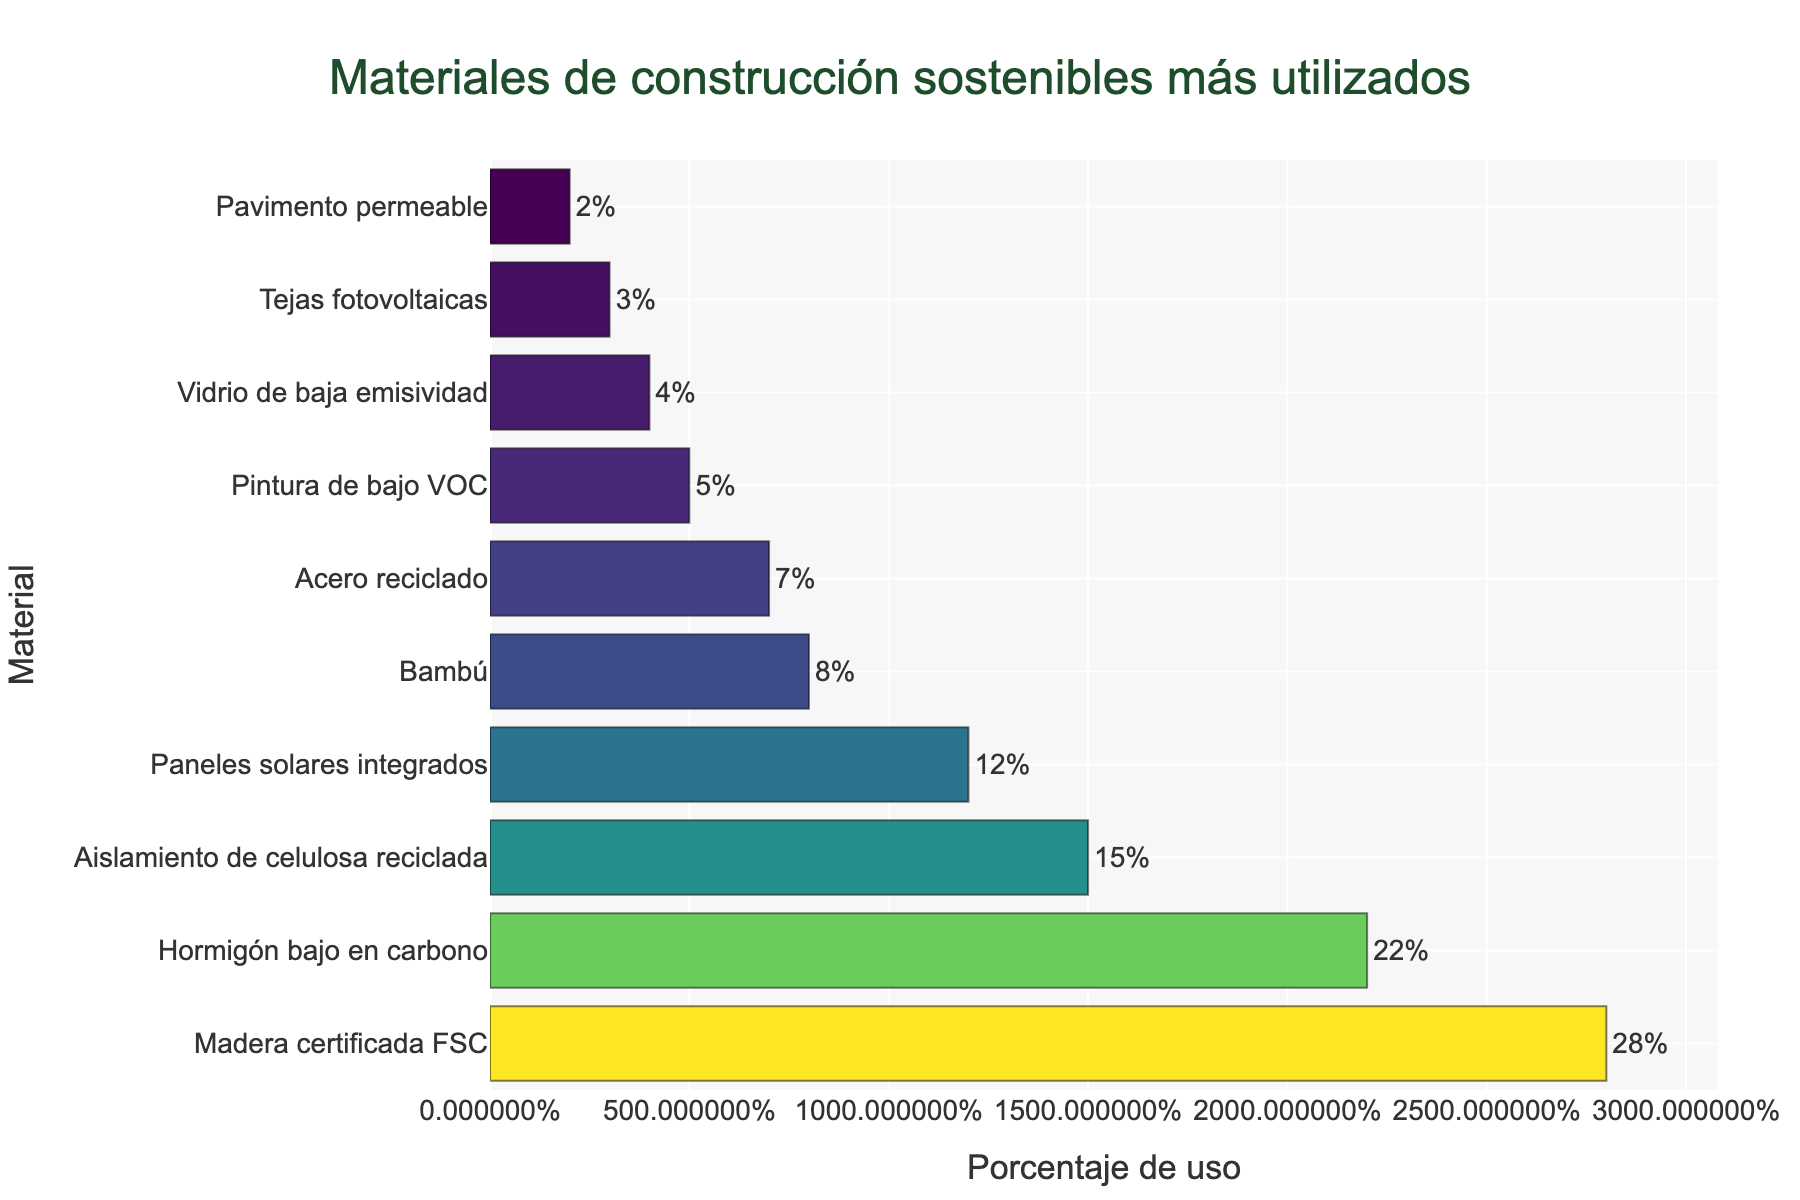¿Cuál es el material de construcción sostenible más utilizado? Observando el gráfico, el material con el porcentaje más alto de uso es "Madera certificada FSC" con un 28%.
Answer: Madera certificada FSC ¿Cuál es el porcentaje de uso combinado de Hormigón bajo en carbono y Aislamiento de celulosa reciclada? Sumamos los porcentajes de uso de ambos materiales: 22% (Hormigón) + 15% (Aislamiento) = 37%.
Answer: 37% Comparando el uso de Bambú y Acero reciclado, ¿cuál es mayor y por cuánto? El uso de Bambú es 8%, mientras que el uso de Acero reciclado es 7%. La diferencia es 8% - 7% = 1%. Por lo tanto, Bambú se usa un 1% más que el Acero reciclado.
Answer: Bambú, 1% ¿Cuál es la diferencia en el porcentaje de uso entre el material más utilizado y el menos utilizado? El material más utilizado es "Madera certificada FSC" con 28% y el menos utilizado es "Pavimento permeable" con 2%. La diferencia es 28% - 2% = 26%.
Answer: 26% ¿Qué porcentaje de uso tiene Pintura de bajo VOC comparado con Vidrio de baja emisividad? La Pintura de bajo VOC tiene un uso del 5%, mientras que el Vidrio de baja emisividad tiene un uso del 4%. La comparación muestra que la pintura tiene un 1% más de uso que el vidrio.
Answer: 1% Si sumamos los porcentajes de uso de los tres materiales más utilizados, ¿qué resultado obtenemos? Sumamos los porcentajes de "Madera certificada FSC" (28%), "Hormigón bajo en carbono" (22%) y "Aislamiento de celulosa reciclada" (15%): 28% + 22% + 15% = 65%.
Answer: 65% ¿Cuáles son los dos materiales menos utilizados y cuál es la diferencia en sus porcentajes de uso? Los dos materiales menos utilizados son "Pavimento permeable" con 2% y "Tejas fotovoltaicas" con 3%. La diferencia en sus porcentajes de uso es 3% - 2% = 1%.
Answer: Pavimento permeable y Tejas fotovoltaicas, 1% ¿Cuál es el promedio del porcentaje de uso de Aislamiento de celulosa reciclada, Pintura de bajo VOC y Paneles solares integrados? Sumamos los porcentajes de los tres materiales: 15% (Aislamiento) + 5% (Pintura) + 12% (Paneles solares) = 32%. Luego, dividimos por 3: 32% / 3 ≈ 10.67%.
Answer: 10.67% En términos de porcentaje de uso, ¿cómo se comparan los paneles solares integrados y las tejas fotovoltaicas? Los paneles solares integrados tienen un uso del 12%, mientras que las tejas fotovoltaicas tienen un uso del 3%. Los paneles solares integrados tienen un uso 9% mayor que las tejas fotovoltaicas.
Answer: Los paneles solares integrados tienen un uso 9% mayor ¿Cuáles materiales tienen un porcentaje de uso menor al 10% y cuáles son esos porcentajes? Los materiales con un porcentaje de uso menor al 10% son Bambú (8%), Acero reciclado (7%), Pintura de bajo VOC (5%), Vidrio de baja emisividad (4%), Tejas fotovoltaicas (3%) y Pavimento permeable (2%).
Answer: Bambú - 8%, Acero reciclado - 7%, Pintura de bajo VOC - 5%, Vidrio de baja emisividad - 4%, Tejas fotovoltaicas - 3%, Pavimento permeable - 2% 